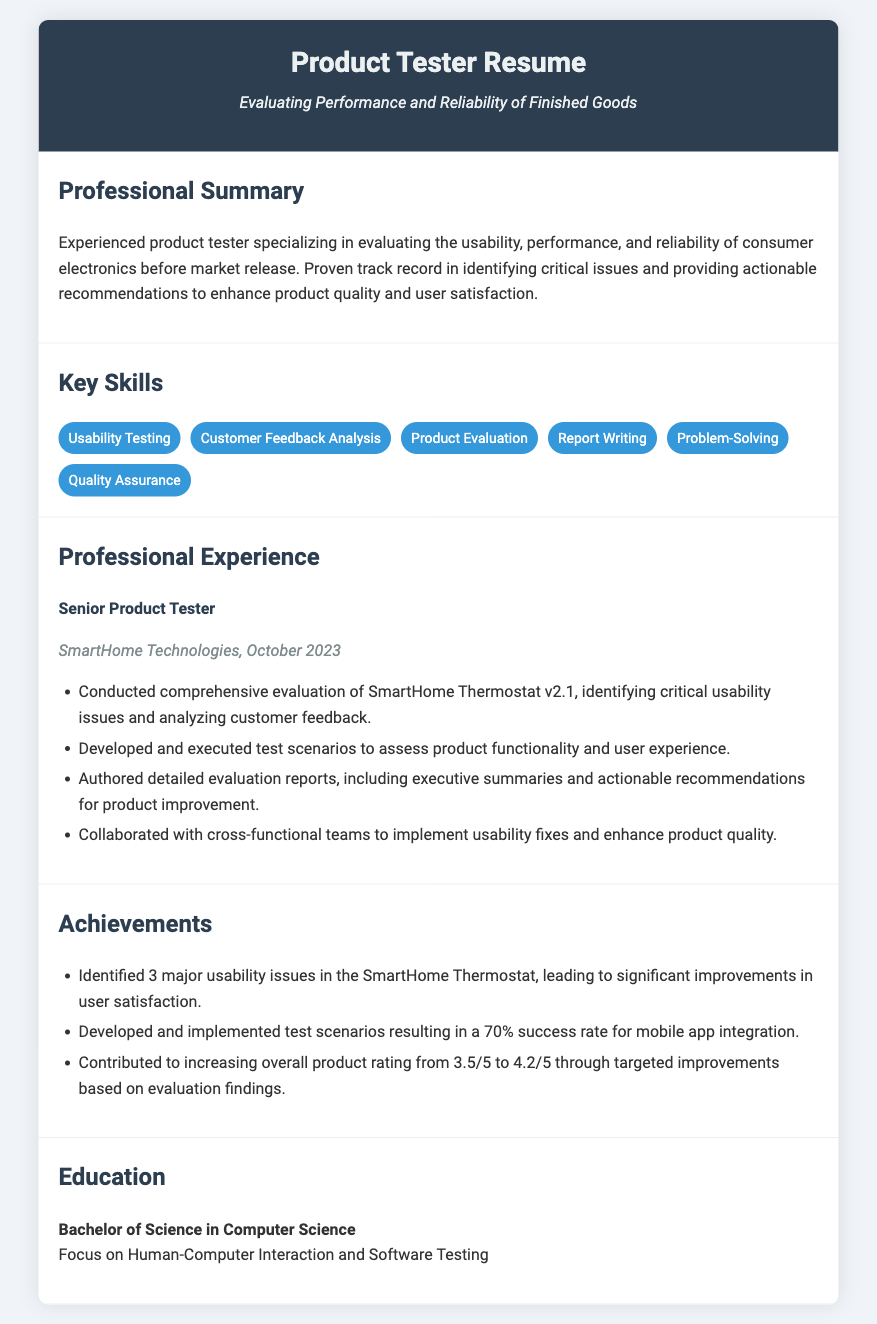what is the job title mentioned in the document? The job title is stated in the 'Professional Experience' section, identifying the position held by the applicant.
Answer: Senior Product Tester which company did the applicant work for? The company name is presented alongside the job title in the Professional Experience section.
Answer: SmartHome Technologies what is one of the skills listed in the resume? The skills are summarized in the 'Key Skills' section, providing a quick list of the applicant's capabilities.
Answer: Usability Testing how many major usability issues were identified? This information is specified under the 'Achievements' section, quantifying the issues discovered by the applicant.
Answer: 3 what was the overall product rating increase? The rating increase is mentioned in the 'Achievements' section, showcasing the improvement as a result of the applicant's efforts.
Answer: 0.7 what date did the applicant work at SmartHome Technologies? The date is provided in the 'Professional Experience' section, indicating the timeframe of employment.
Answer: October 2023 which degree did the applicant attain? The educational background is detailed in the 'Education' section, noting the highest degree achieved by the applicant.
Answer: Bachelor of Science in Computer Science what was the success rate for mobile app integration? This percentage is mentioned in the 'Achievements' section, reflecting the effectiveness of the applicant's test scenarios.
Answer: 70% 